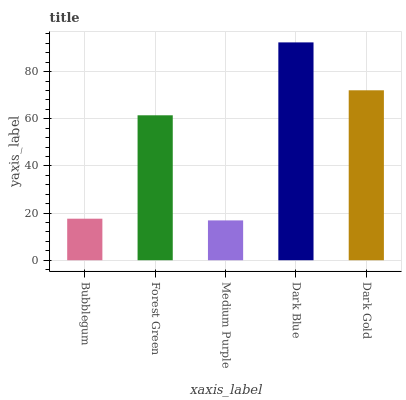Is Forest Green the minimum?
Answer yes or no. No. Is Forest Green the maximum?
Answer yes or no. No. Is Forest Green greater than Bubblegum?
Answer yes or no. Yes. Is Bubblegum less than Forest Green?
Answer yes or no. Yes. Is Bubblegum greater than Forest Green?
Answer yes or no. No. Is Forest Green less than Bubblegum?
Answer yes or no. No. Is Forest Green the high median?
Answer yes or no. Yes. Is Forest Green the low median?
Answer yes or no. Yes. Is Dark Blue the high median?
Answer yes or no. No. Is Dark Gold the low median?
Answer yes or no. No. 